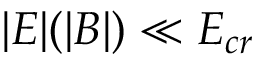Convert formula to latex. <formula><loc_0><loc_0><loc_500><loc_500>| E | ( | B | ) \ll E _ { c r }</formula> 